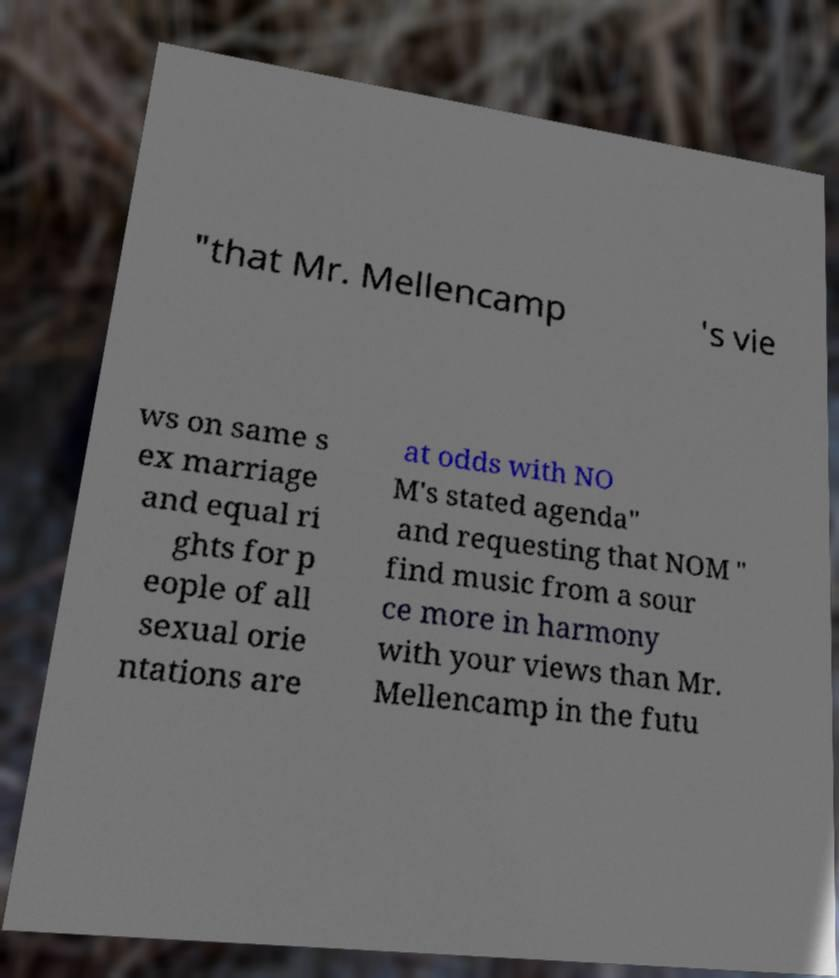Can you read and provide the text displayed in the image?This photo seems to have some interesting text. Can you extract and type it out for me? "that Mr. Mellencamp 's vie ws on same s ex marriage and equal ri ghts for p eople of all sexual orie ntations are at odds with NO M's stated agenda" and requesting that NOM " find music from a sour ce more in harmony with your views than Mr. Mellencamp in the futu 